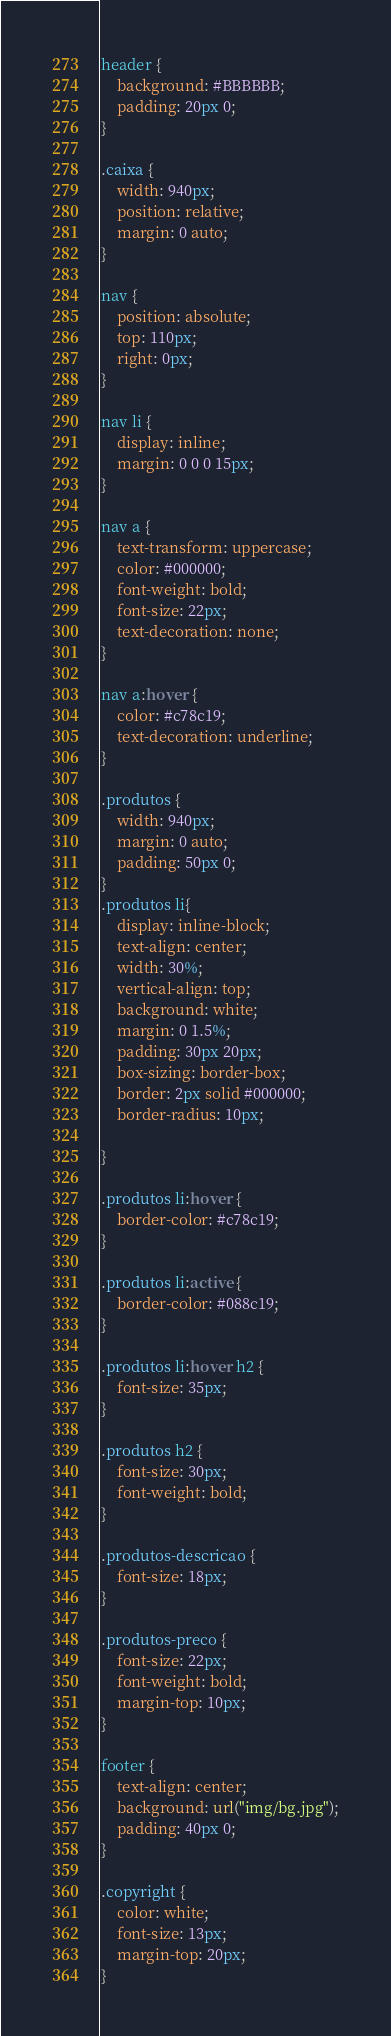Convert code to text. <code><loc_0><loc_0><loc_500><loc_500><_CSS_>header {
    background: #BBBBBB;
    padding: 20px 0;
}

.caixa {
    width: 940px;
    position: relative;
    margin: 0 auto;
}

nav {
    position: absolute;
    top: 110px;
    right: 0px;
}

nav li {
    display: inline;
    margin: 0 0 0 15px;
}

nav a {
    text-transform: uppercase;
    color: #000000;
    font-weight: bold;
    font-size: 22px;
    text-decoration: none;
}

nav a:hover {
    color: #c78c19;
    text-decoration: underline;
}

.produtos {
    width: 940px;
    margin: 0 auto;
    padding: 50px 0;
}
.produtos li{
    display: inline-block;
    text-align: center;
    width: 30%; 
    vertical-align: top;
    background: white;   
    margin: 0 1.5%;
    padding: 30px 20px; 
    box-sizing: border-box;
    border: 2px solid #000000;
    border-radius: 10px;

}

.produtos li:hover {
    border-color: #c78c19;
}

.produtos li:active {
    border-color: #088c19;
}

.produtos li:hover h2 {
    font-size: 35px;
}

.produtos h2 {
    font-size: 30px;
    font-weight: bold;
}

.produtos-descricao {
    font-size: 18px;    
}

.produtos-preco {
    font-size: 22px;
    font-weight: bold;
    margin-top: 10px;
}

footer {
    text-align: center;
    background: url("img/bg.jpg");
    padding: 40px 0;
}

.copyright {
    color: white;
    font-size: 13px;
    margin-top: 20px;
}</code> 